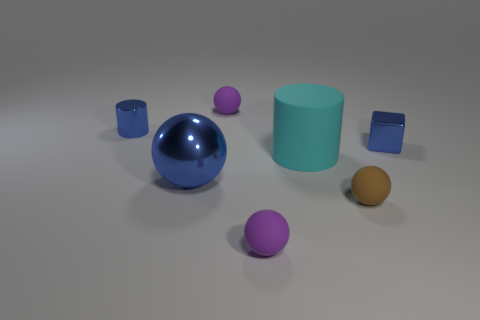Add 2 brown balls. How many objects exist? 9 Subtract all spheres. How many objects are left? 3 Add 6 big cyan rubber things. How many big cyan rubber things exist? 7 Subtract 0 red spheres. How many objects are left? 7 Subtract all big matte cylinders. Subtract all tiny brown balls. How many objects are left? 5 Add 6 small blue things. How many small blue things are left? 8 